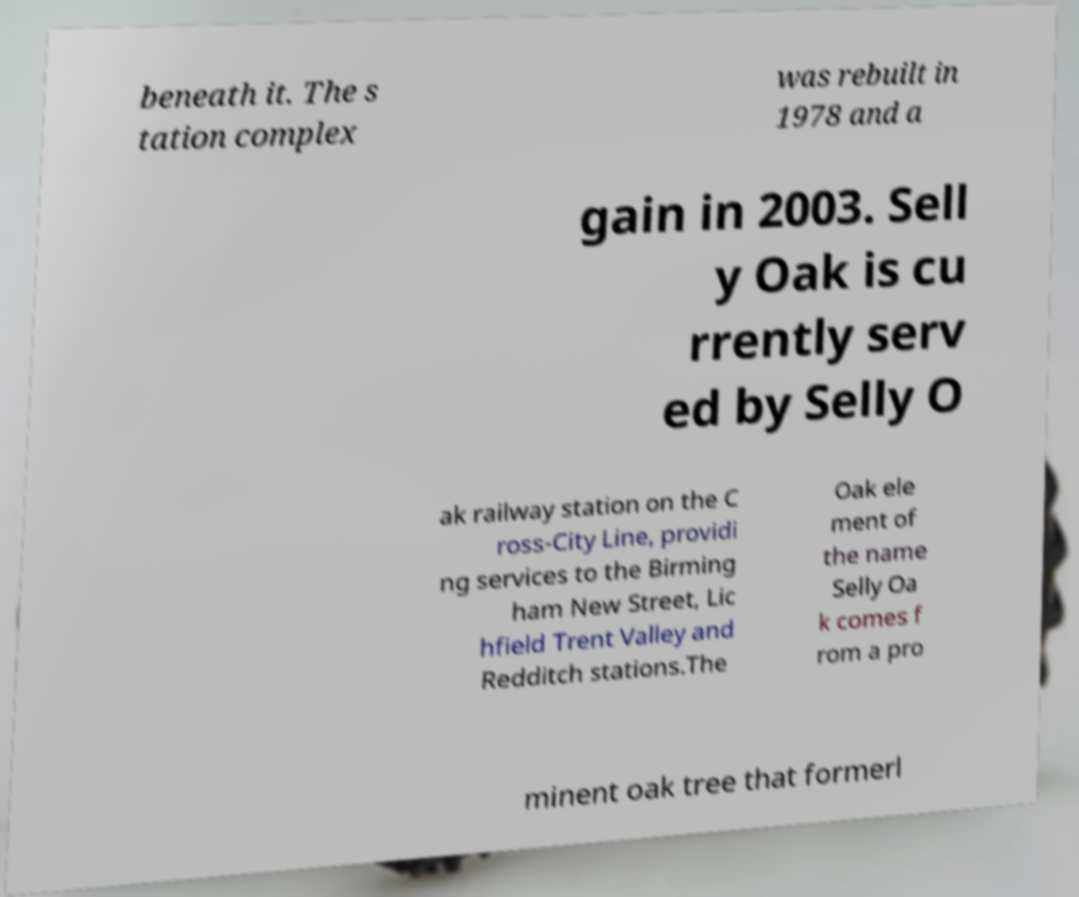There's text embedded in this image that I need extracted. Can you transcribe it verbatim? beneath it. The s tation complex was rebuilt in 1978 and a gain in 2003. Sell y Oak is cu rrently serv ed by Selly O ak railway station on the C ross-City Line, providi ng services to the Birming ham New Street, Lic hfield Trent Valley and Redditch stations.The Oak ele ment of the name Selly Oa k comes f rom a pro minent oak tree that formerl 